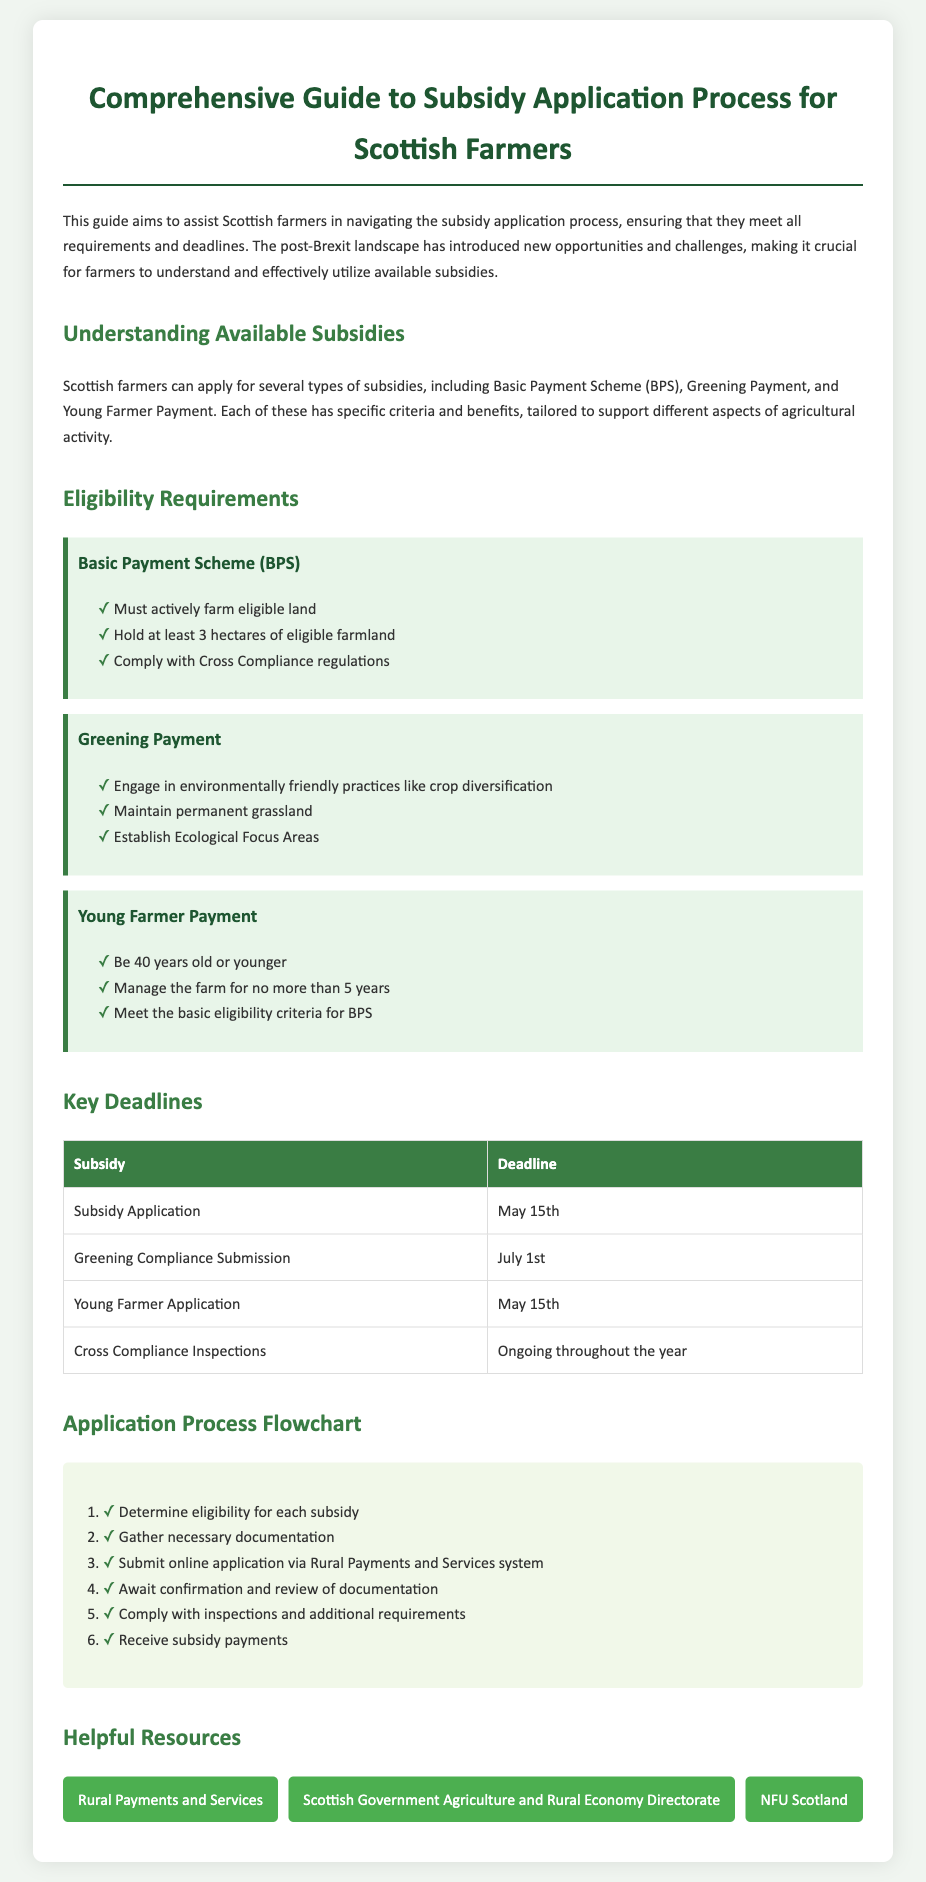What are the three types of subsidies available for Scottish farmers? The document outlines the Basic Payment Scheme, Greening Payment, and Young Farmer Payment as available subsidies.
Answer: Basic Payment Scheme, Greening Payment, Young Farmer Payment What is the deadline for subsidy application? The document specifies the deadline for subsidy application as May 15th.
Answer: May 15th What is the age limit for the Young Farmer Payment? According to the document, the eligibility criteria state that an applicant must be 40 years old or younger for the Young Farmer Payment.
Answer: 40 What is the first step in the application process flowchart? The first step in the process flowchart is to determine eligibility for each subsidy.
Answer: Determine eligibility What document should farmers refer to for information on rural payments? The document provides a link to the Rural Payments and Services website as a helpful resource.
Answer: Rural Payments and Services What are the ongoing compliance inspections related to? The document mentions that Cross Compliance Inspections are ongoing throughout the year, related to the compliance requirements for subsidies.
Answer: Cross Compliance Inspections What is one requirement for the Greening Payment? The document states that to qualify for the Greening Payment, farmers must maintain permanent grassland among other requirements.
Answer: Maintain permanent grassland How many hectares of eligible farmland must be held to qualify for BPS? The eligibility requirement for the Basic Payment Scheme specifies that a farmer must hold at least 3 hectares of eligible farmland.
Answer: 3 hectares Which organization provides guidance on agriculture policy in Scotland? The document lists NFU Scotland as one of the helpful resources for guidance on agricultural policy and support.
Answer: NFU Scotland 